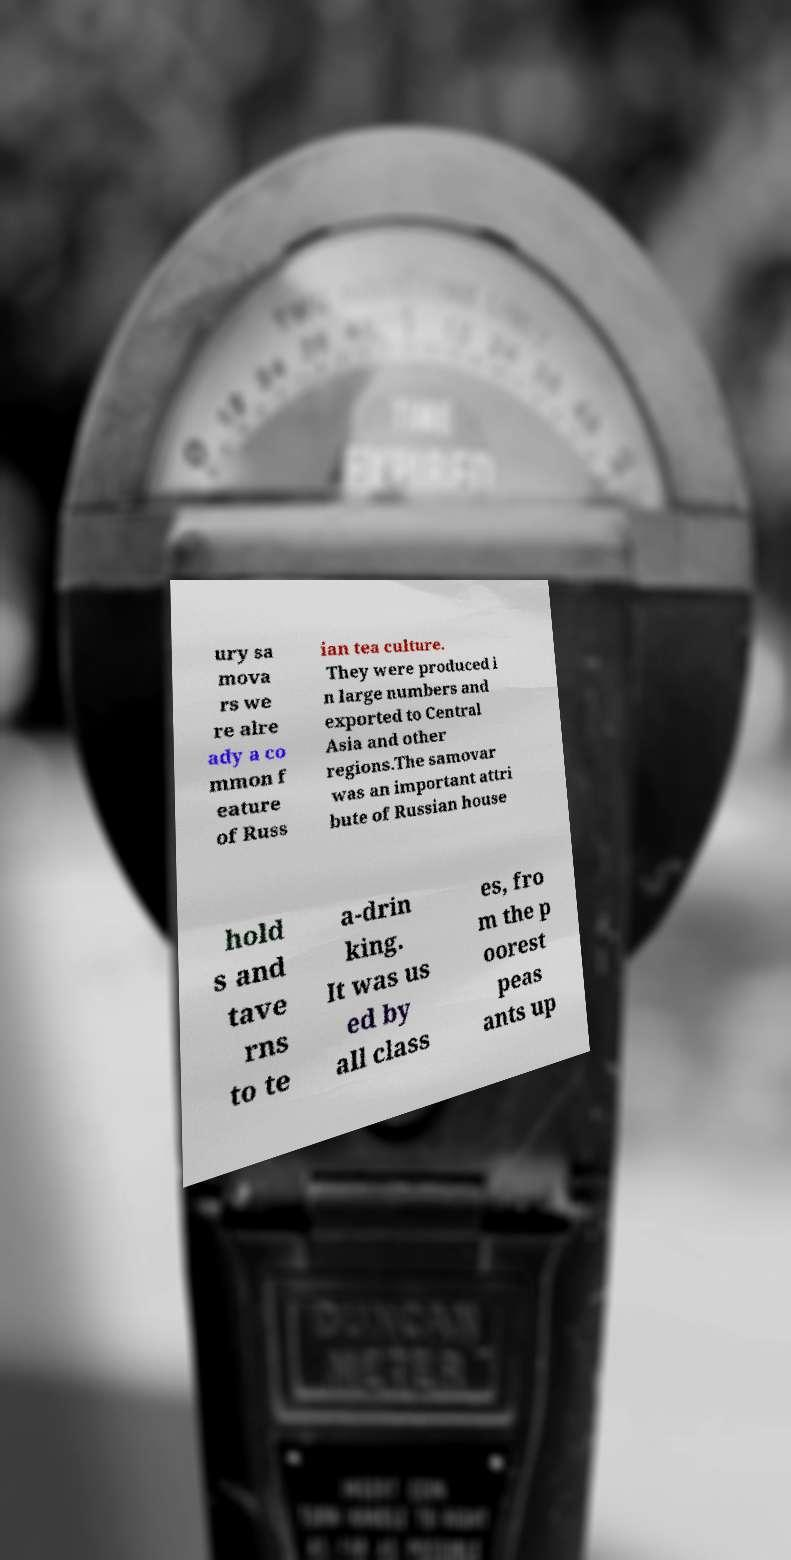Could you assist in decoding the text presented in this image and type it out clearly? ury sa mova rs we re alre ady a co mmon f eature of Russ ian tea culture. They were produced i n large numbers and exported to Central Asia and other regions.The samovar was an important attri bute of Russian house hold s and tave rns to te a-drin king. It was us ed by all class es, fro m the p oorest peas ants up 